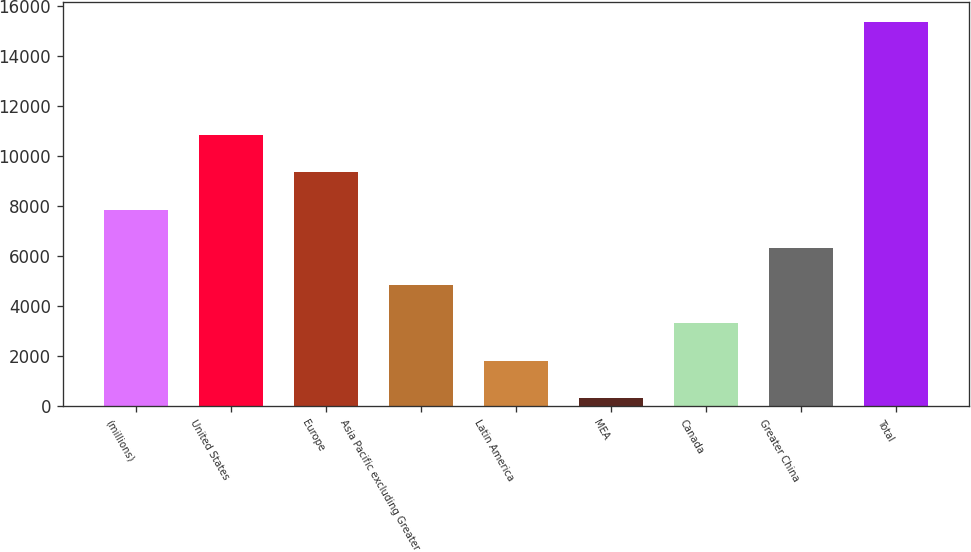<chart> <loc_0><loc_0><loc_500><loc_500><bar_chart><fcel>(millions)<fcel>United States<fcel>Europe<fcel>Asia Pacific excluding Greater<fcel>Latin America<fcel>MEA<fcel>Canada<fcel>Greater China<fcel>Total<nl><fcel>7838.05<fcel>10849.2<fcel>9343.64<fcel>4826.87<fcel>1815.69<fcel>310.1<fcel>3321.28<fcel>6332.46<fcel>15366<nl></chart> 